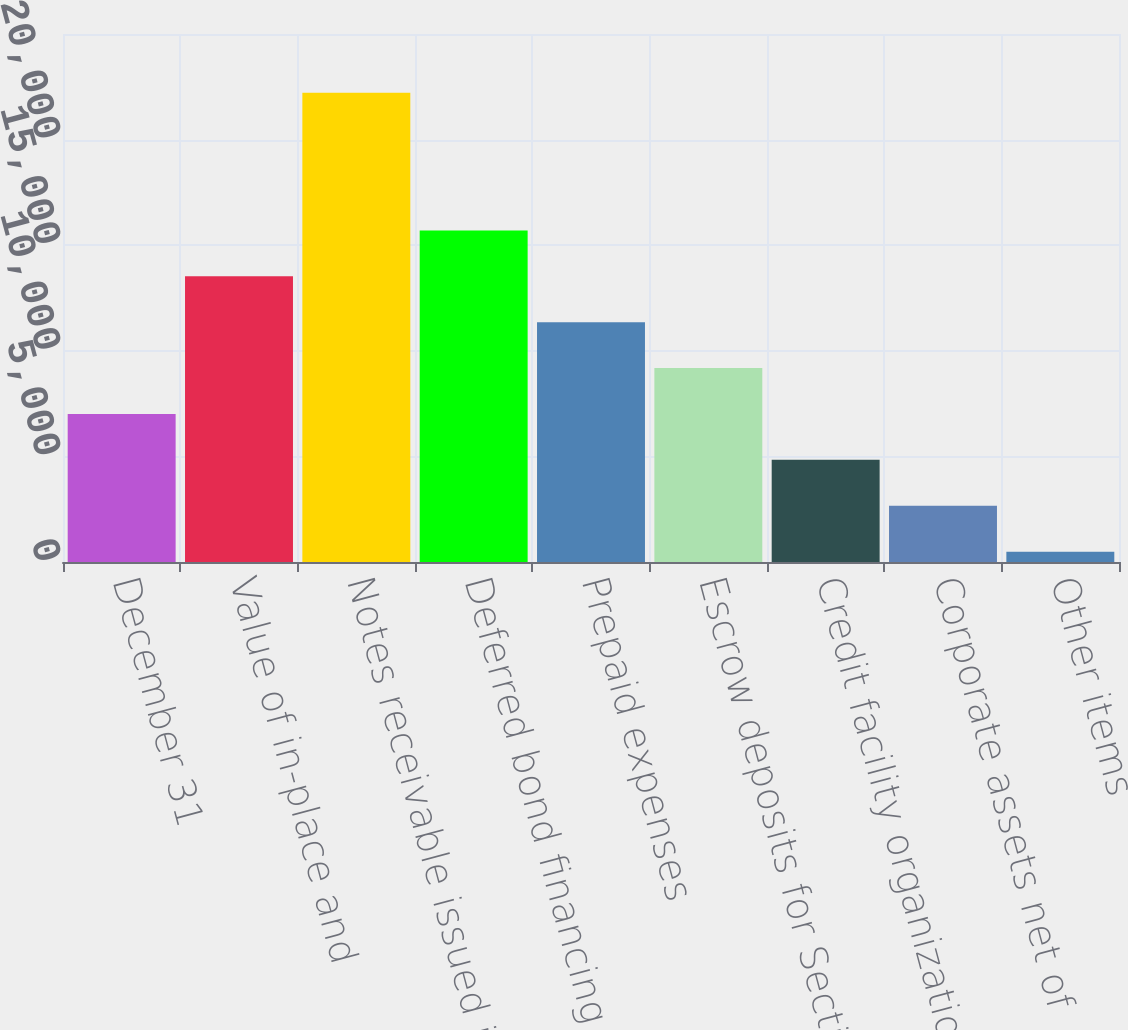Convert chart to OTSL. <chart><loc_0><loc_0><loc_500><loc_500><bar_chart><fcel>December 31<fcel>Value of in-place and<fcel>Notes receivable issued in<fcel>Deferred bond financing costs<fcel>Prepaid expenses<fcel>Escrow deposits for Section<fcel>Credit facility organization<fcel>Corporate assets net of<fcel>Other items<nl><fcel>7007.9<fcel>13524.8<fcel>22214<fcel>15697.1<fcel>11352.5<fcel>9180.2<fcel>4835.6<fcel>2663.3<fcel>491<nl></chart> 